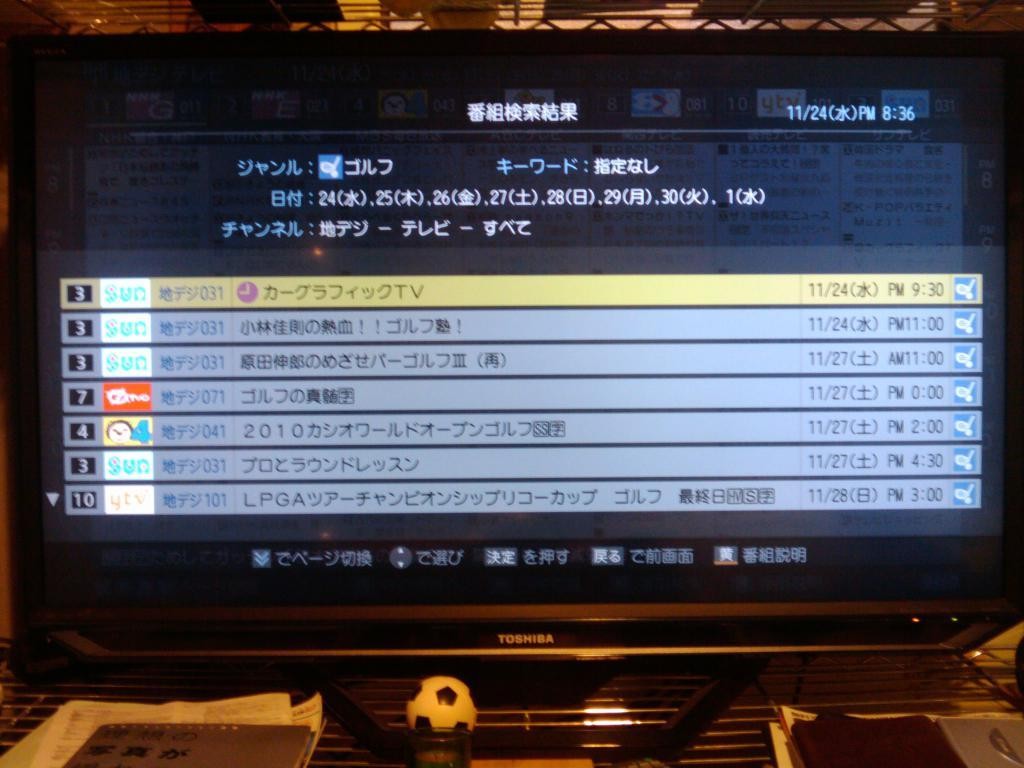What electronic device is visible in the image? There is a monitor in the image. What type of object can be seen besides the monitor? There is a ball and papers visible in the image. What is the surface on which the monitor and other objects are placed? There are objects on the table in the image. What is displayed on the monitor? The monitor displays some information. How many ducks are present at the party in the image? There are no ducks or party depicted in the image. What type of sheep can be seen grazing on the table in the image? There are no sheep present in the image; the table contains objects such as a monitor, ball, and papers. 